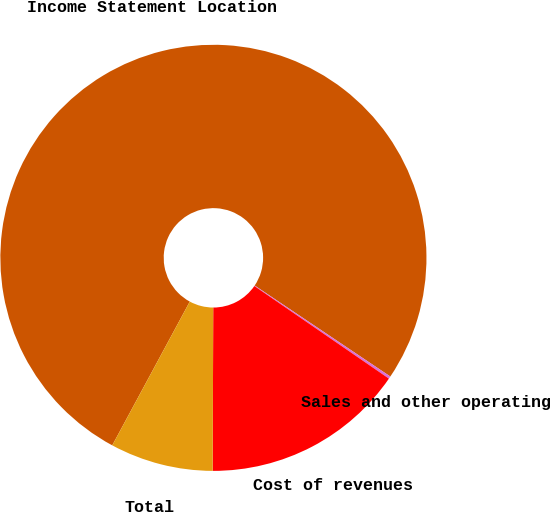Convert chart to OTSL. <chart><loc_0><loc_0><loc_500><loc_500><pie_chart><fcel>Income Statement Location<fcel>Sales and other operating<fcel>Cost of revenues<fcel>Total<nl><fcel>76.53%<fcel>0.19%<fcel>15.46%<fcel>7.82%<nl></chart> 